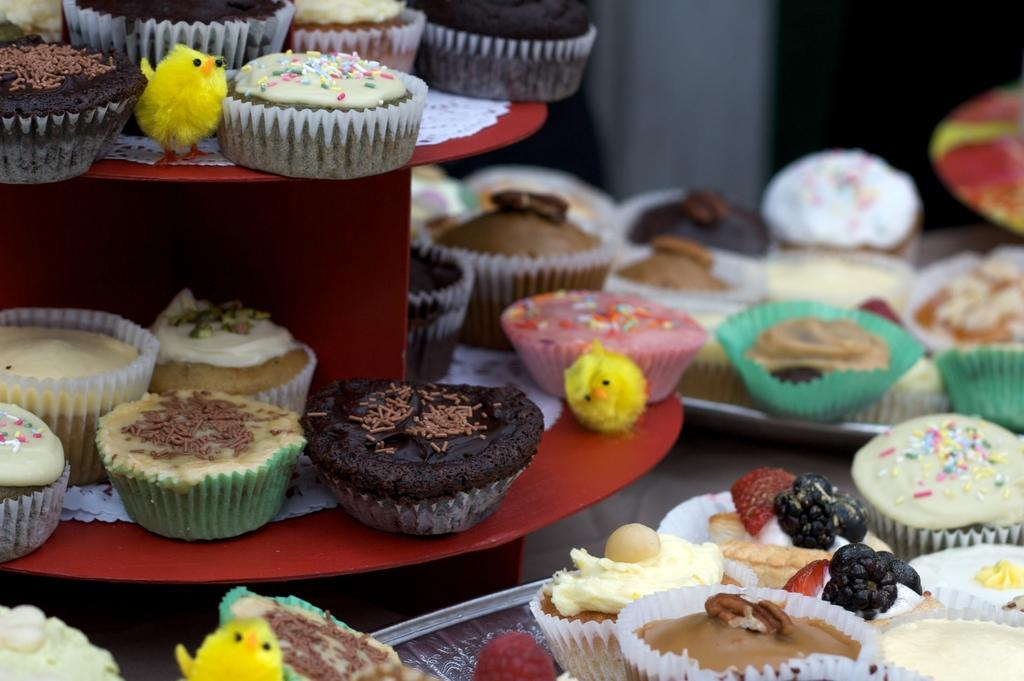What is the main piece of furniture in the image? There is a table in the image. What type of food items can be seen on the table? There are cupcakes on the table. What other items are present on the table besides food? There are toys, plates, trays, and cloths on the table. What type of wrench is being used to cut the cupcakes in the image? There is no wrench present in the image, and cupcakes are not being cut. 